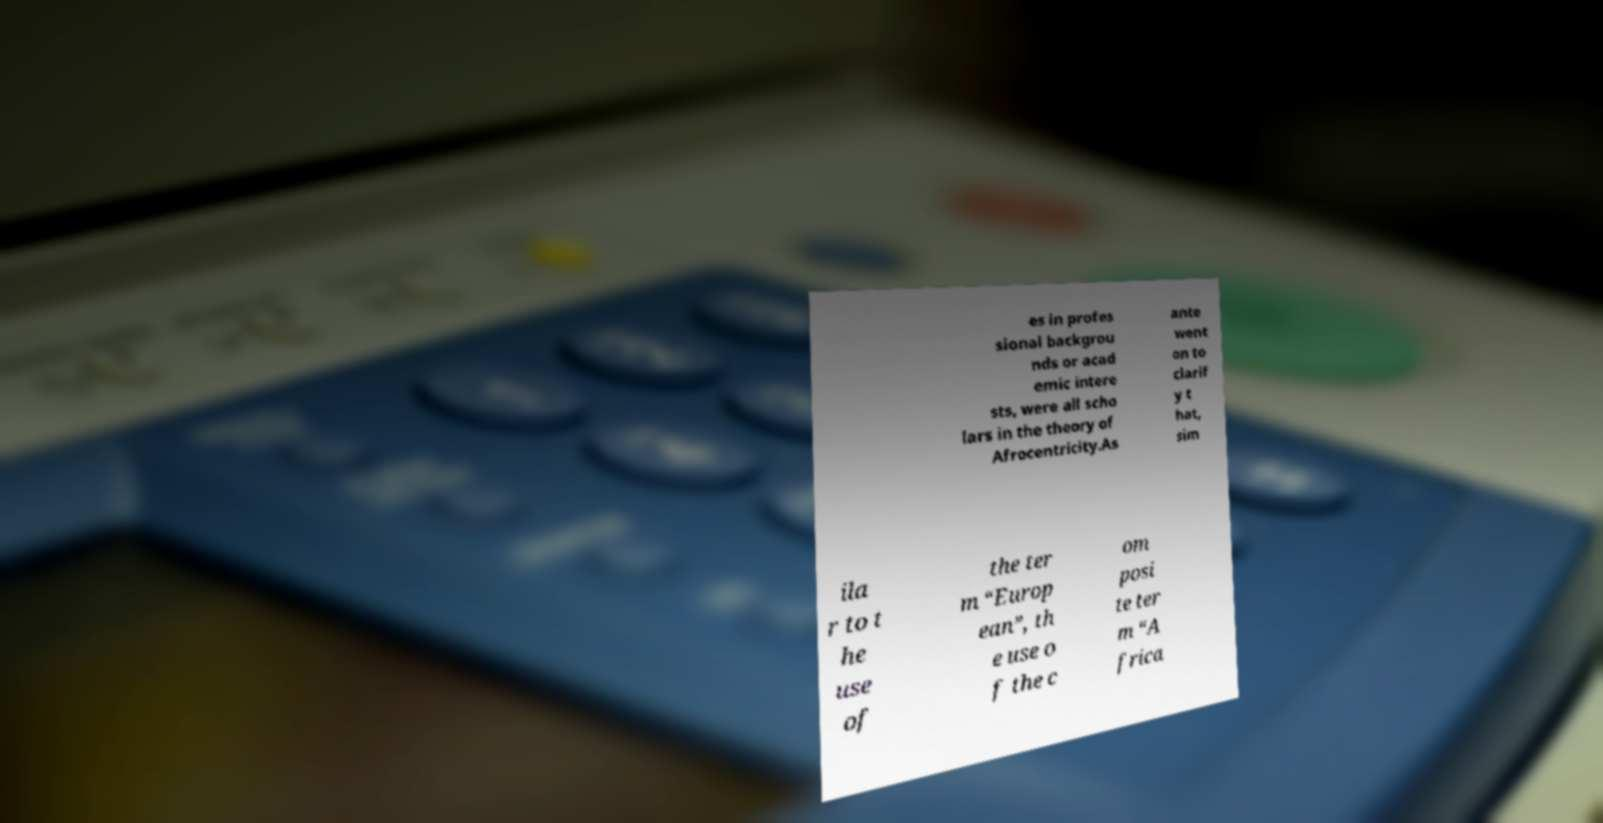For documentation purposes, I need the text within this image transcribed. Could you provide that? es in profes sional backgrou nds or acad emic intere sts, were all scho lars in the theory of Afrocentricity.As ante went on to clarif y t hat, sim ila r to t he use of the ter m “Europ ean”, th e use o f the c om posi te ter m “A frica 